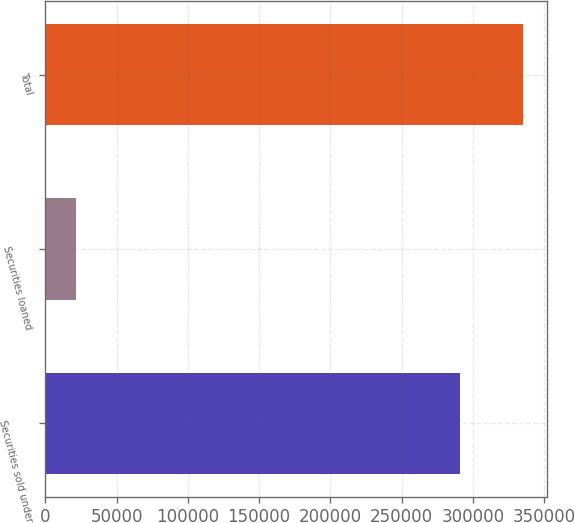Convert chart to OTSL. <chart><loc_0><loc_0><loc_500><loc_500><bar_chart><fcel>Securities sold under<fcel>Securities loaned<fcel>Total<nl><fcel>290895<fcel>21687<fcel>335293<nl></chart> 